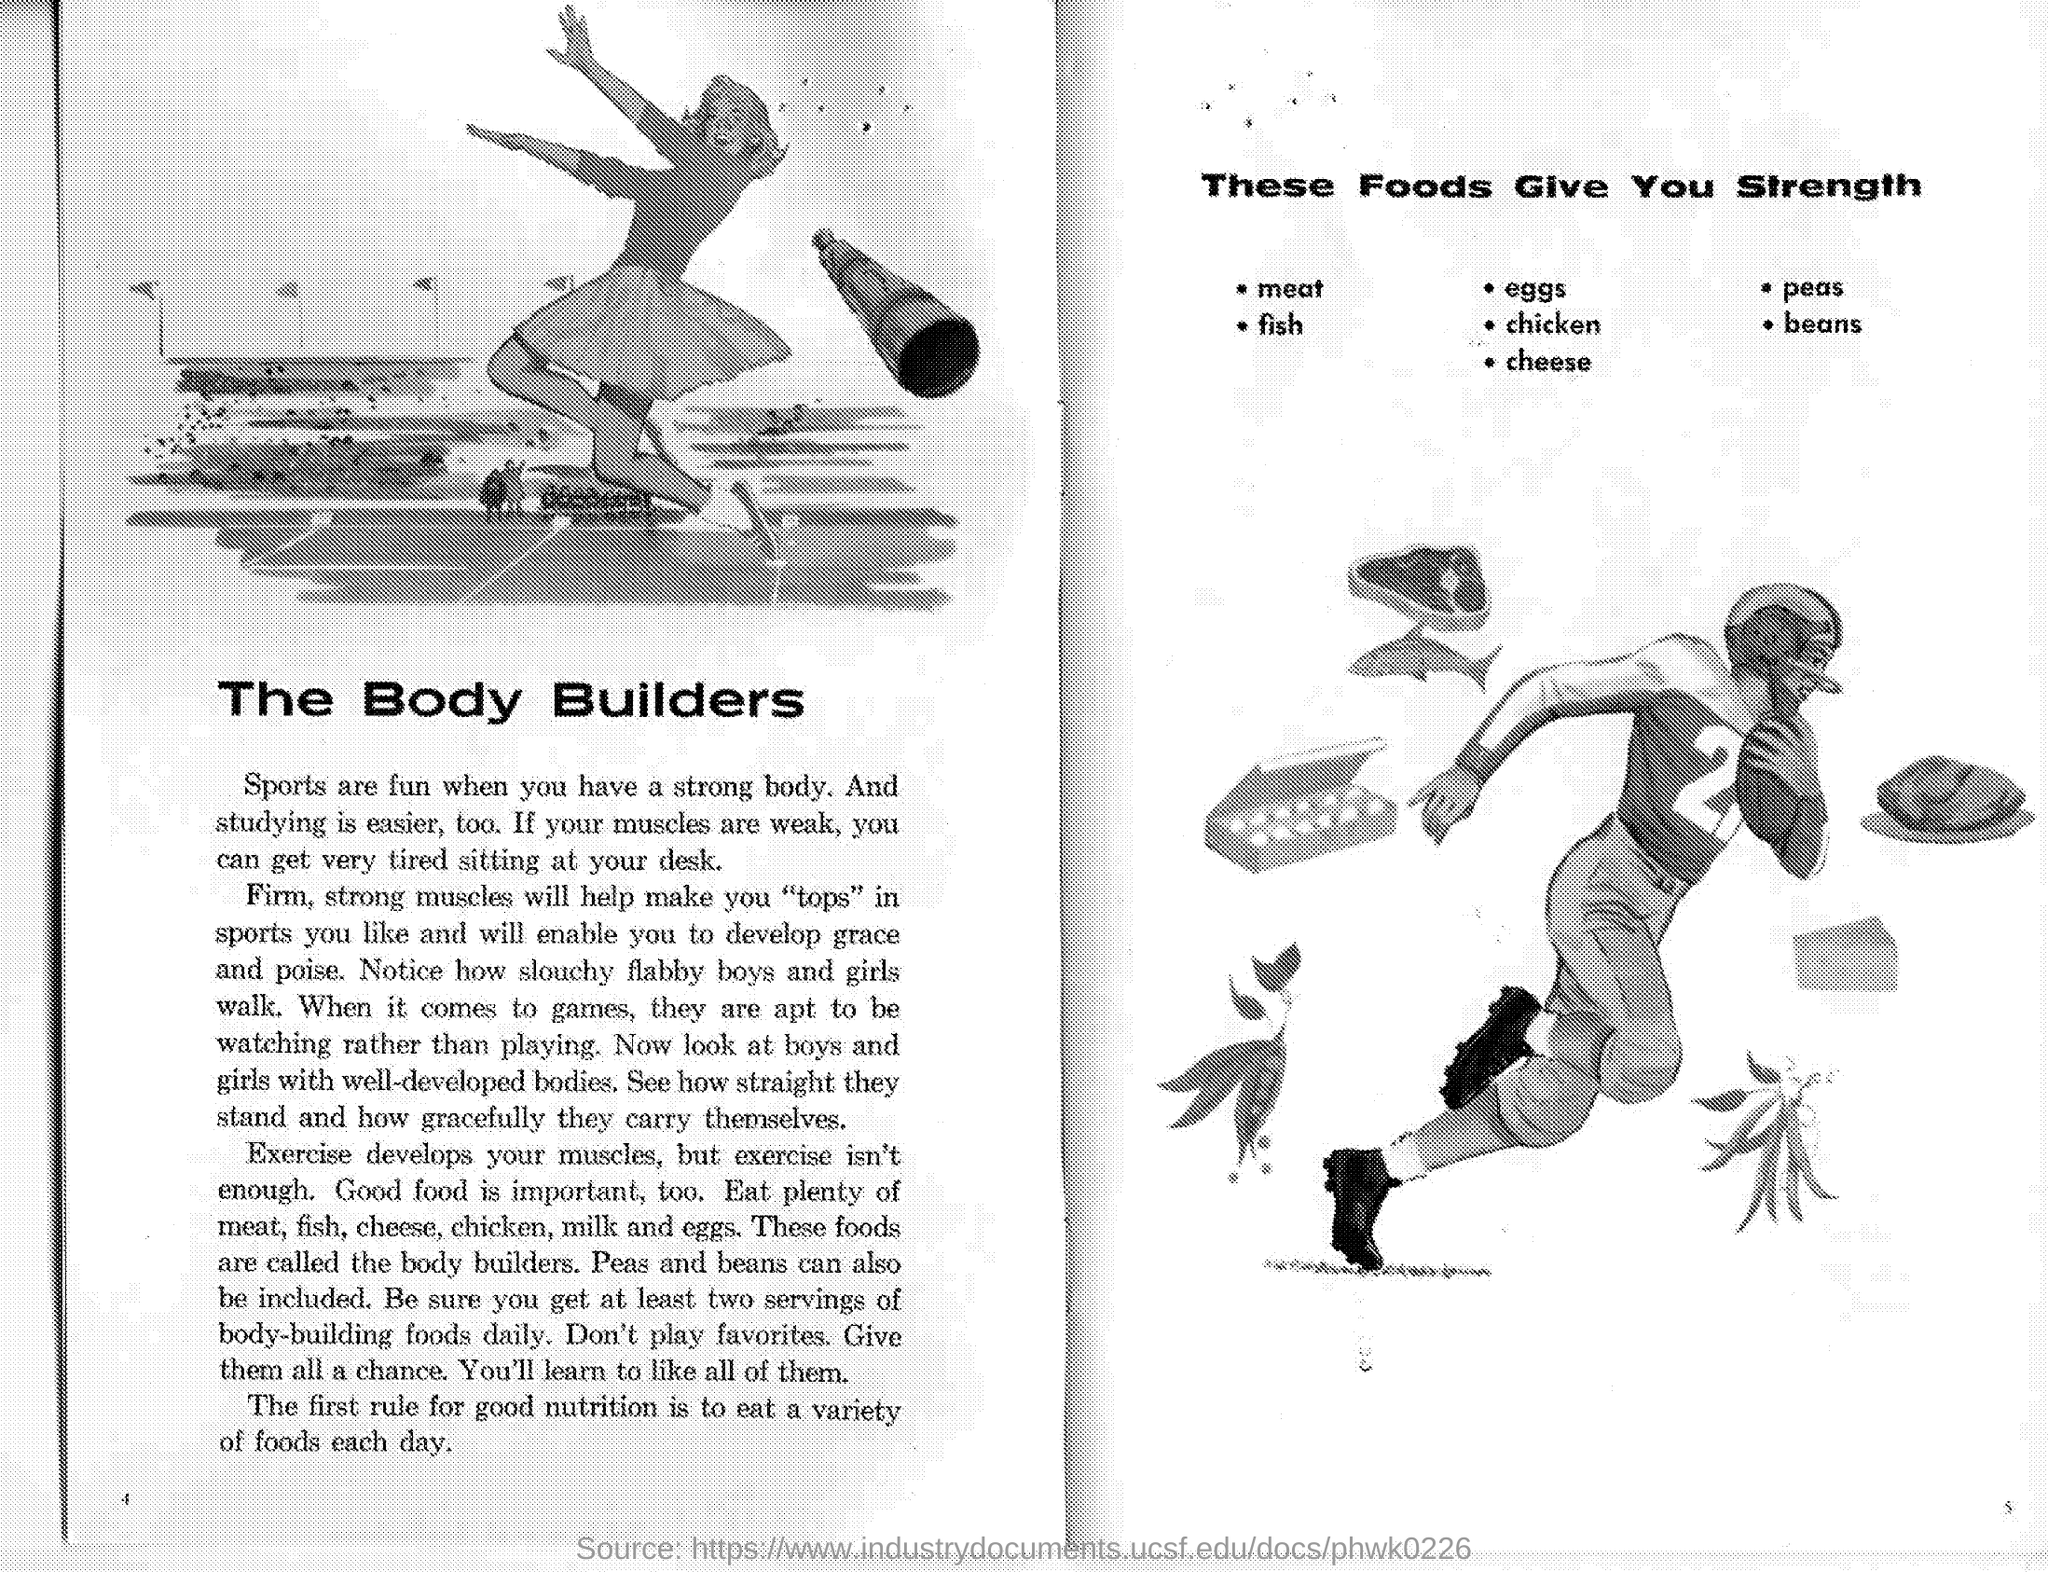Name the food that gives you strength starting with "F"?
Offer a terse response. Fish. Name the food that gives you strength starting with "E"?
Ensure brevity in your answer.  Eggs. Name the food that gives you strength starting with "B"?
Keep it short and to the point. Beans. Name the food that gives you strength starting with "P"?
Offer a very short reply. Peas. 